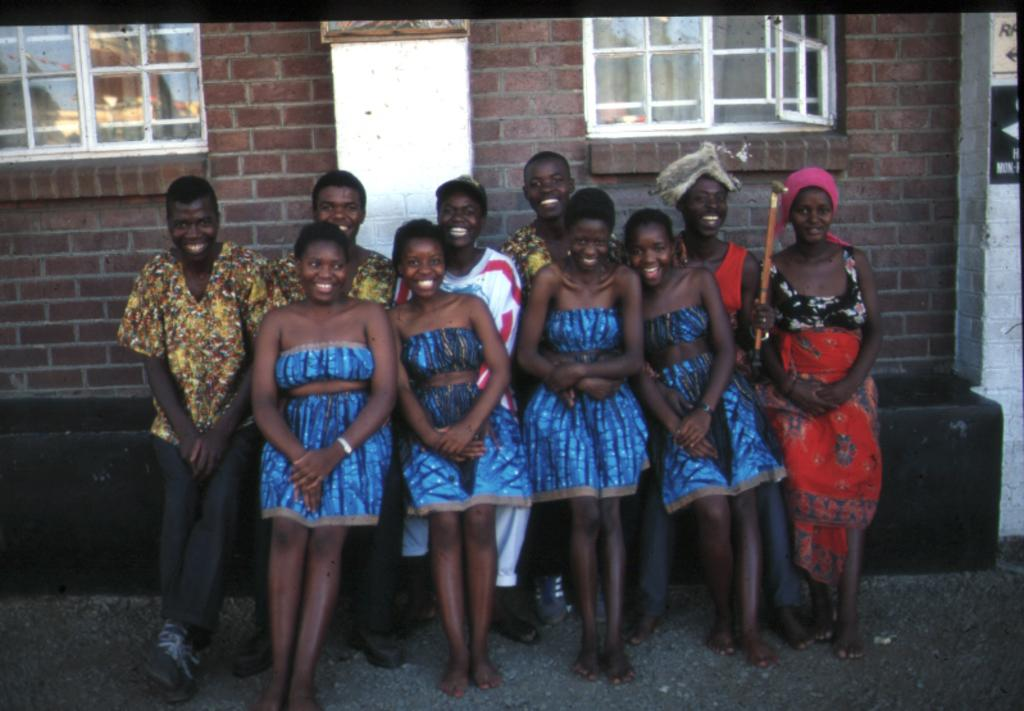What is happening in the image? There are people standing in the image. What structure is visible in the image? There is a building in the image. What feature can be seen on the building? The building has windows. Can you describe the walls in the image? There are walls with windows in the image. What is the current debt situation of the people in the image? There is no information about the debt situation of the people in the image. Is there an alley visible in the image? There is no alley present in the image. 